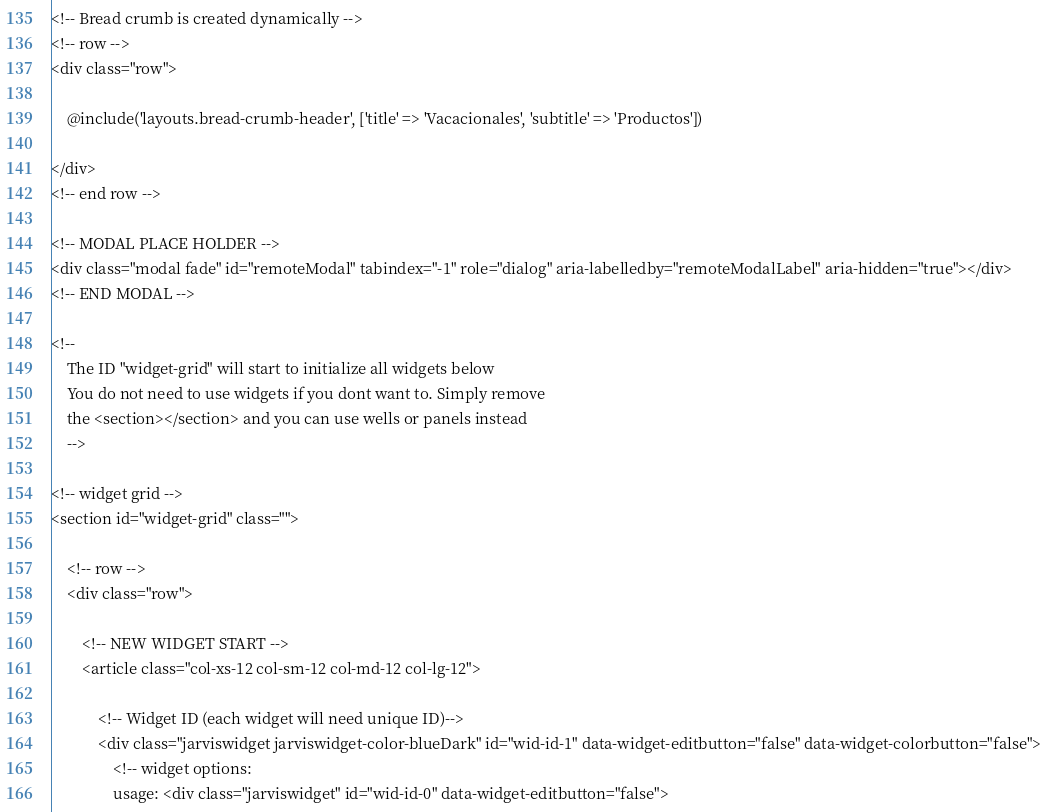<code> <loc_0><loc_0><loc_500><loc_500><_PHP_><!-- Bread crumb is created dynamically -->
<!-- row -->
<div class="row">

    @include('layouts.bread-crumb-header', ['title' => 'Vacacionales', 'subtitle' => 'Productos'])

</div>
<!-- end row -->

<!-- MODAL PLACE HOLDER -->
<div class="modal fade" id="remoteModal" tabindex="-1" role="dialog" aria-labelledby="remoteModalLabel" aria-hidden="true"></div>
<!-- END MODAL -->

<!--
	The ID "widget-grid" will start to initialize all widgets below
	You do not need to use widgets if you dont want to. Simply remove
	the <section></section> and you can use wells or panels instead
	-->

<!-- widget grid -->
<section id="widget-grid" class="">

    <!-- row -->
    <div class="row">

        <!-- NEW WIDGET START -->
        <article class="col-xs-12 col-sm-12 col-md-12 col-lg-12">

            <!-- Widget ID (each widget will need unique ID)-->
            <div class="jarviswidget jarviswidget-color-blueDark" id="wid-id-1" data-widget-editbutton="false" data-widget-colorbutton="false">
                <!-- widget options:
                usage: <div class="jarviswidget" id="wid-id-0" data-widget-editbutton="false">
</code> 